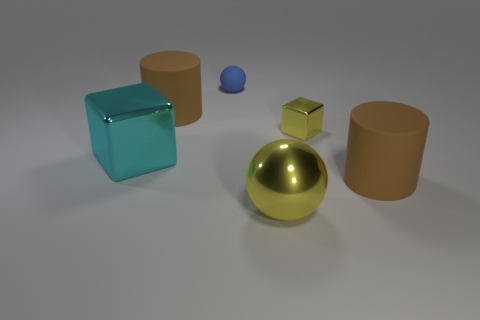There is a shiny block left of the small object behind the small metal object; how big is it?
Your answer should be very brief. Large. Are there more large cyan things that are left of the big cyan object than big metallic objects right of the big yellow metal thing?
Your answer should be compact. No. What number of cylinders are either tiny yellow things or large rubber things?
Keep it short and to the point. 2. Is there any other thing that has the same size as the cyan block?
Keep it short and to the point. Yes. There is a yellow metallic thing in front of the large cyan metal object; does it have the same shape as the cyan thing?
Offer a terse response. No. The large shiny sphere is what color?
Provide a short and direct response. Yellow. What color is the tiny object that is the same shape as the big cyan shiny thing?
Your answer should be very brief. Yellow. How many other objects have the same shape as the cyan object?
Provide a short and direct response. 1. How many things are either cyan blocks or big matte cylinders that are right of the large yellow thing?
Offer a very short reply. 2. There is a large metal sphere; does it have the same color as the large matte thing behind the tiny yellow block?
Offer a terse response. No. 